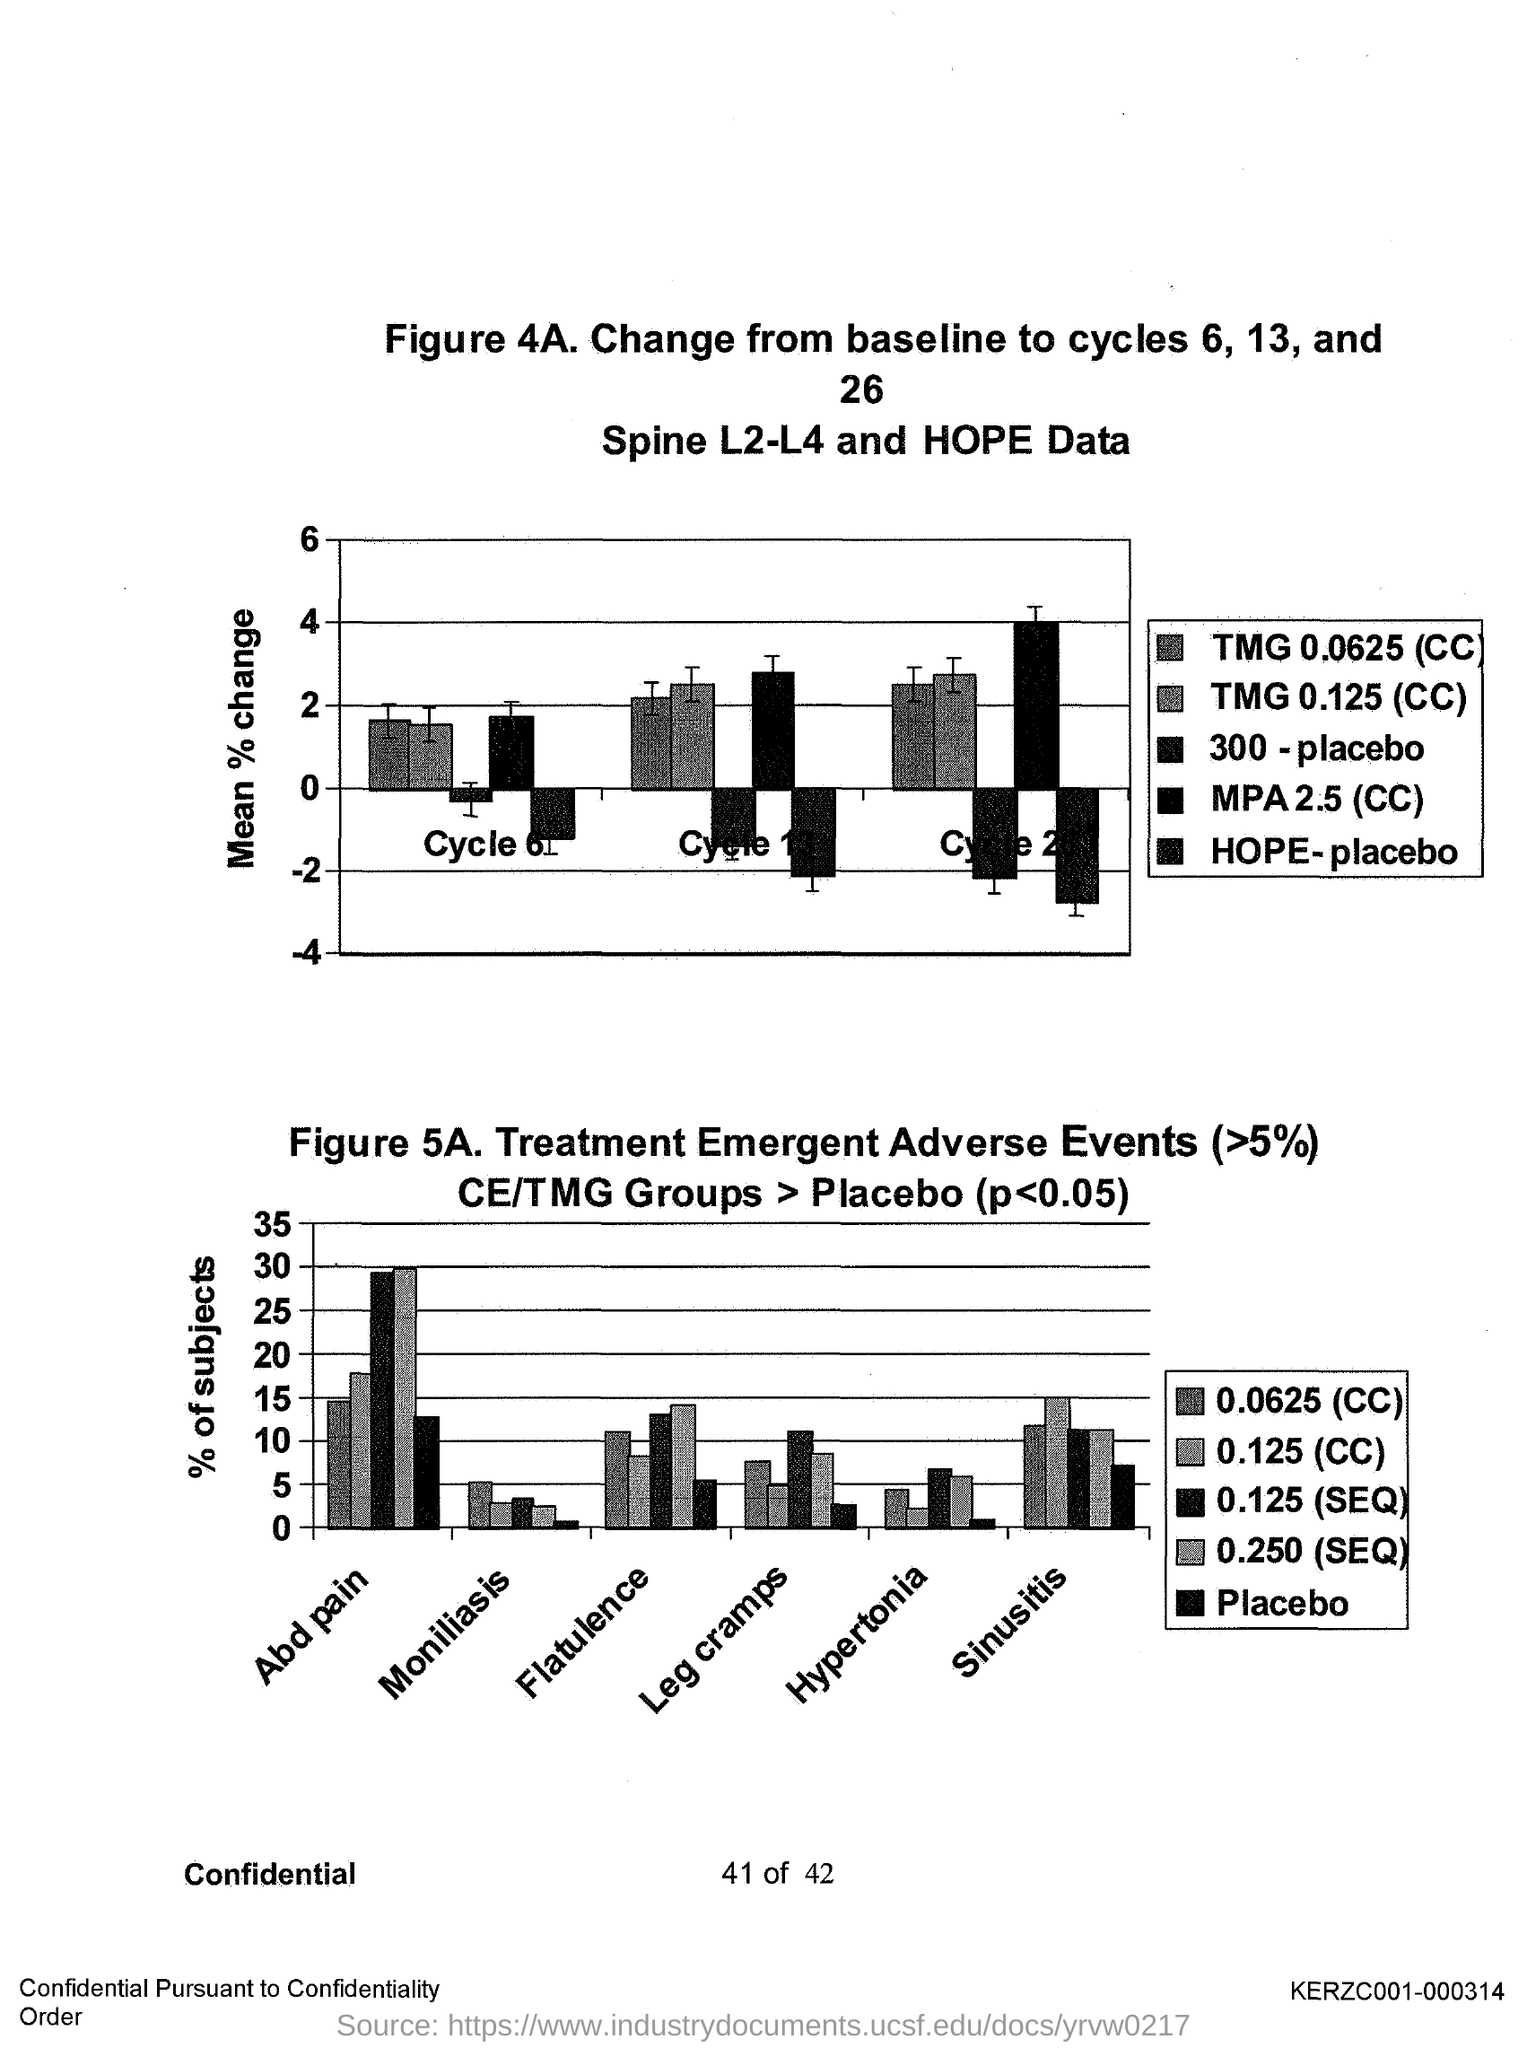Mention a couple of crucial points in this snapshot. The unit on the Y axis of the graph in Figure 4A is Mean Percent Change. The unit on the Y axis of the graph in Figure 5A is "% of subjects". 